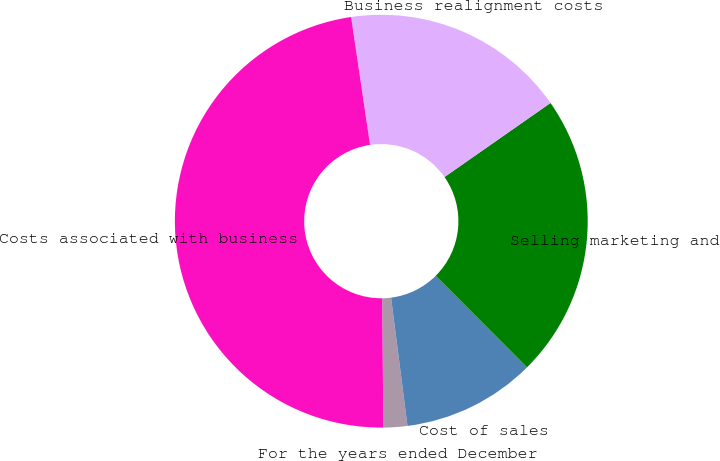Convert chart. <chart><loc_0><loc_0><loc_500><loc_500><pie_chart><fcel>For the years ended December<fcel>Cost of sales<fcel>Selling marketing and<fcel>Business realignment costs<fcel>Costs associated with business<nl><fcel>1.86%<fcel>10.45%<fcel>22.23%<fcel>17.63%<fcel>47.83%<nl></chart> 